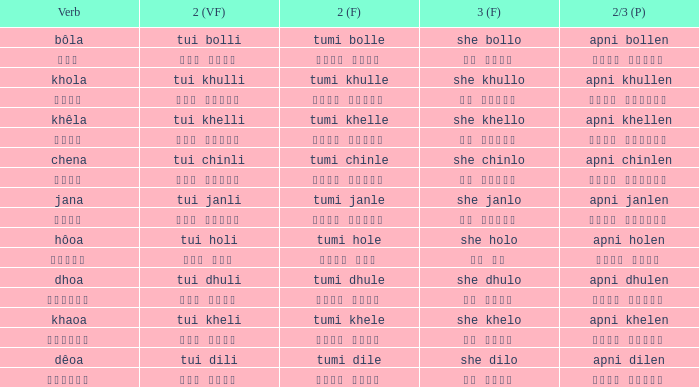What is the 2(vf) for তুমি বললে? তুই বললি. 